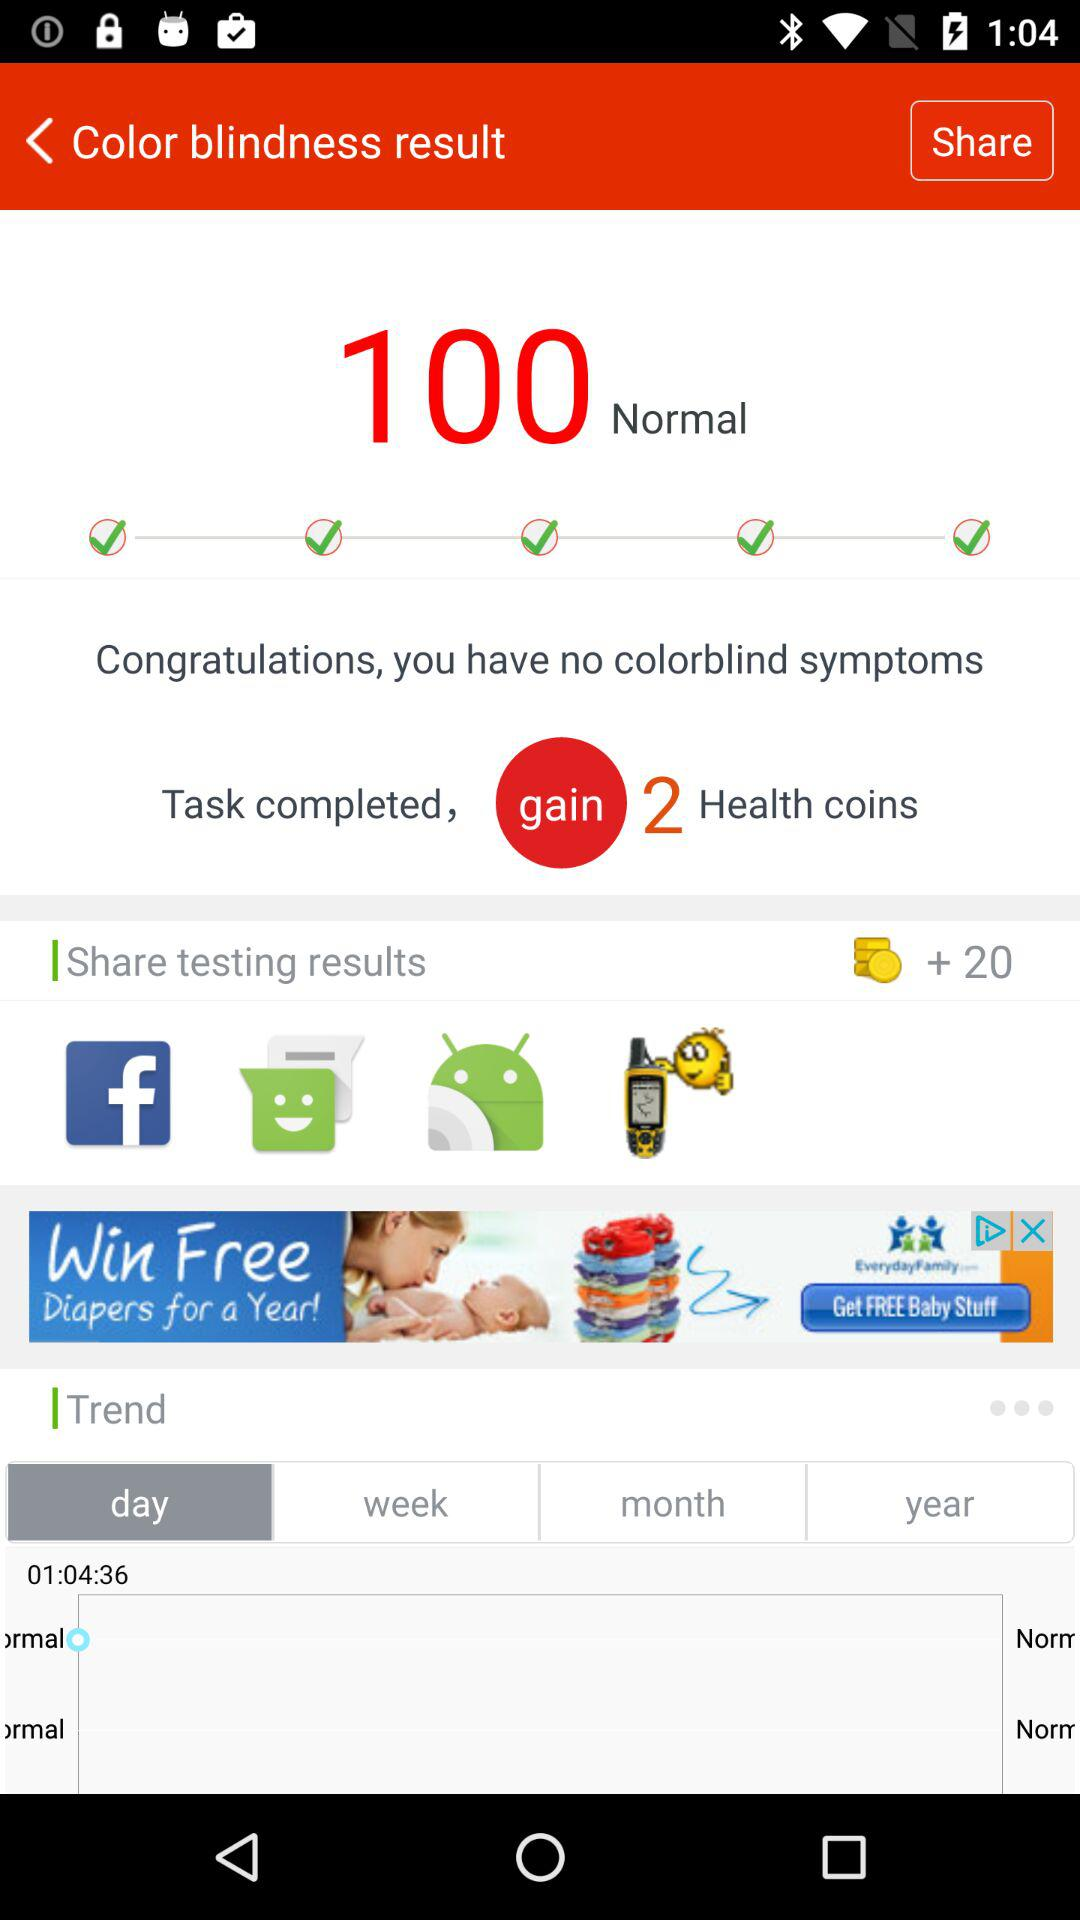What is the selected option in "Trend"? The selected option in "Trend" is "day". 